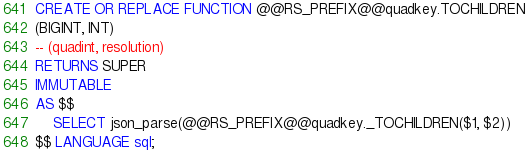<code> <loc_0><loc_0><loc_500><loc_500><_SQL_>CREATE OR REPLACE FUNCTION @@RS_PREFIX@@quadkey.TOCHILDREN
(BIGINT, INT)
-- (quadint, resolution)
RETURNS SUPER
IMMUTABLE
AS $$
    SELECT json_parse(@@RS_PREFIX@@quadkey._TOCHILDREN($1, $2))
$$ LANGUAGE sql;</code> 